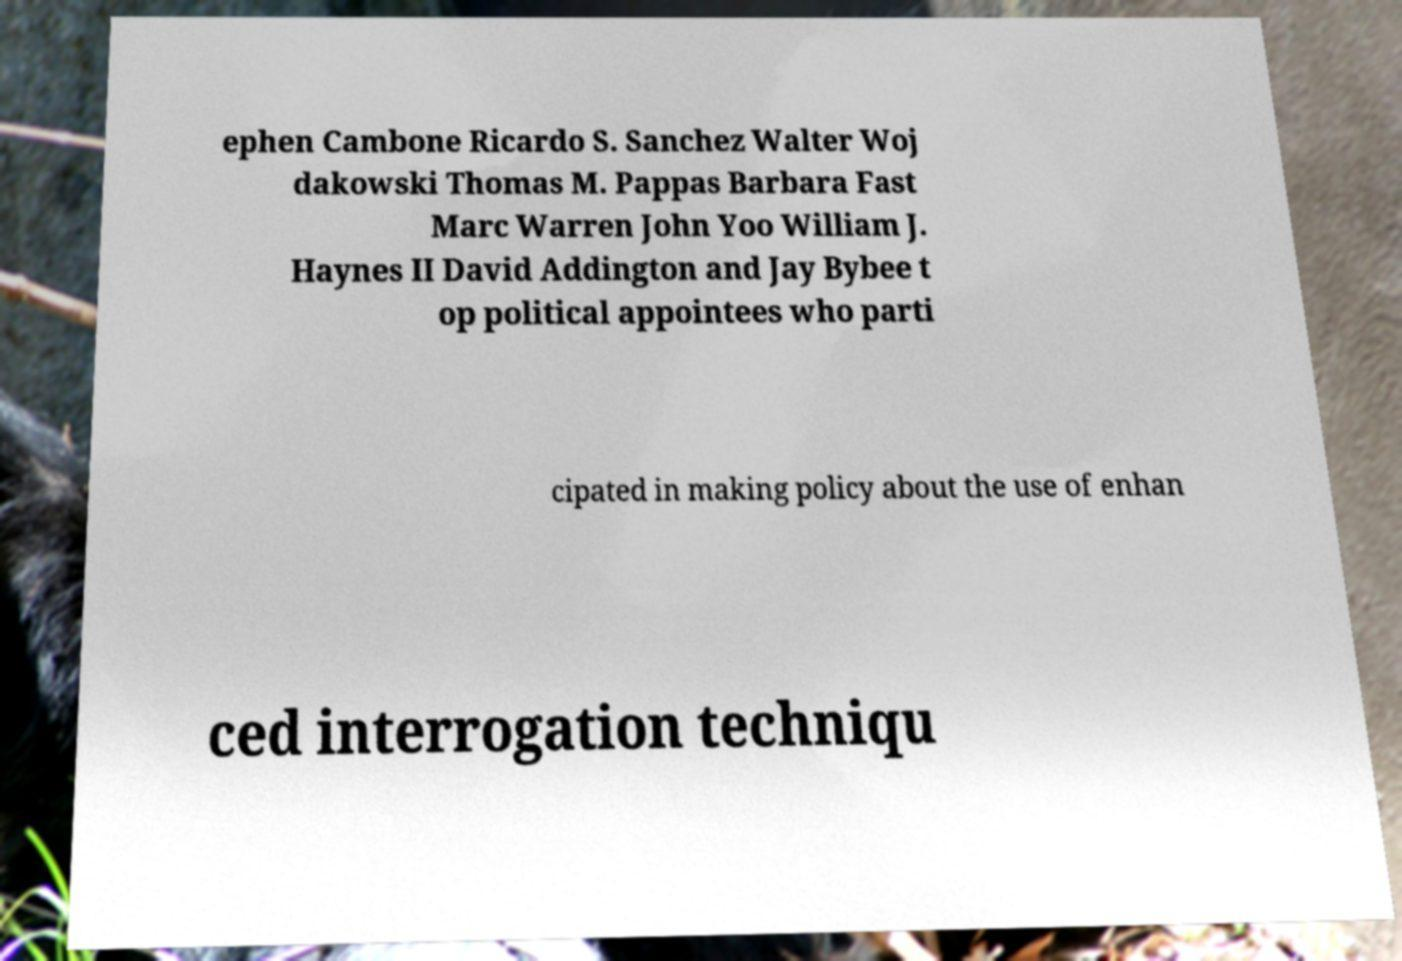There's text embedded in this image that I need extracted. Can you transcribe it verbatim? ephen Cambone Ricardo S. Sanchez Walter Woj dakowski Thomas M. Pappas Barbara Fast Marc Warren John Yoo William J. Haynes II David Addington and Jay Bybee t op political appointees who parti cipated in making policy about the use of enhan ced interrogation techniqu 